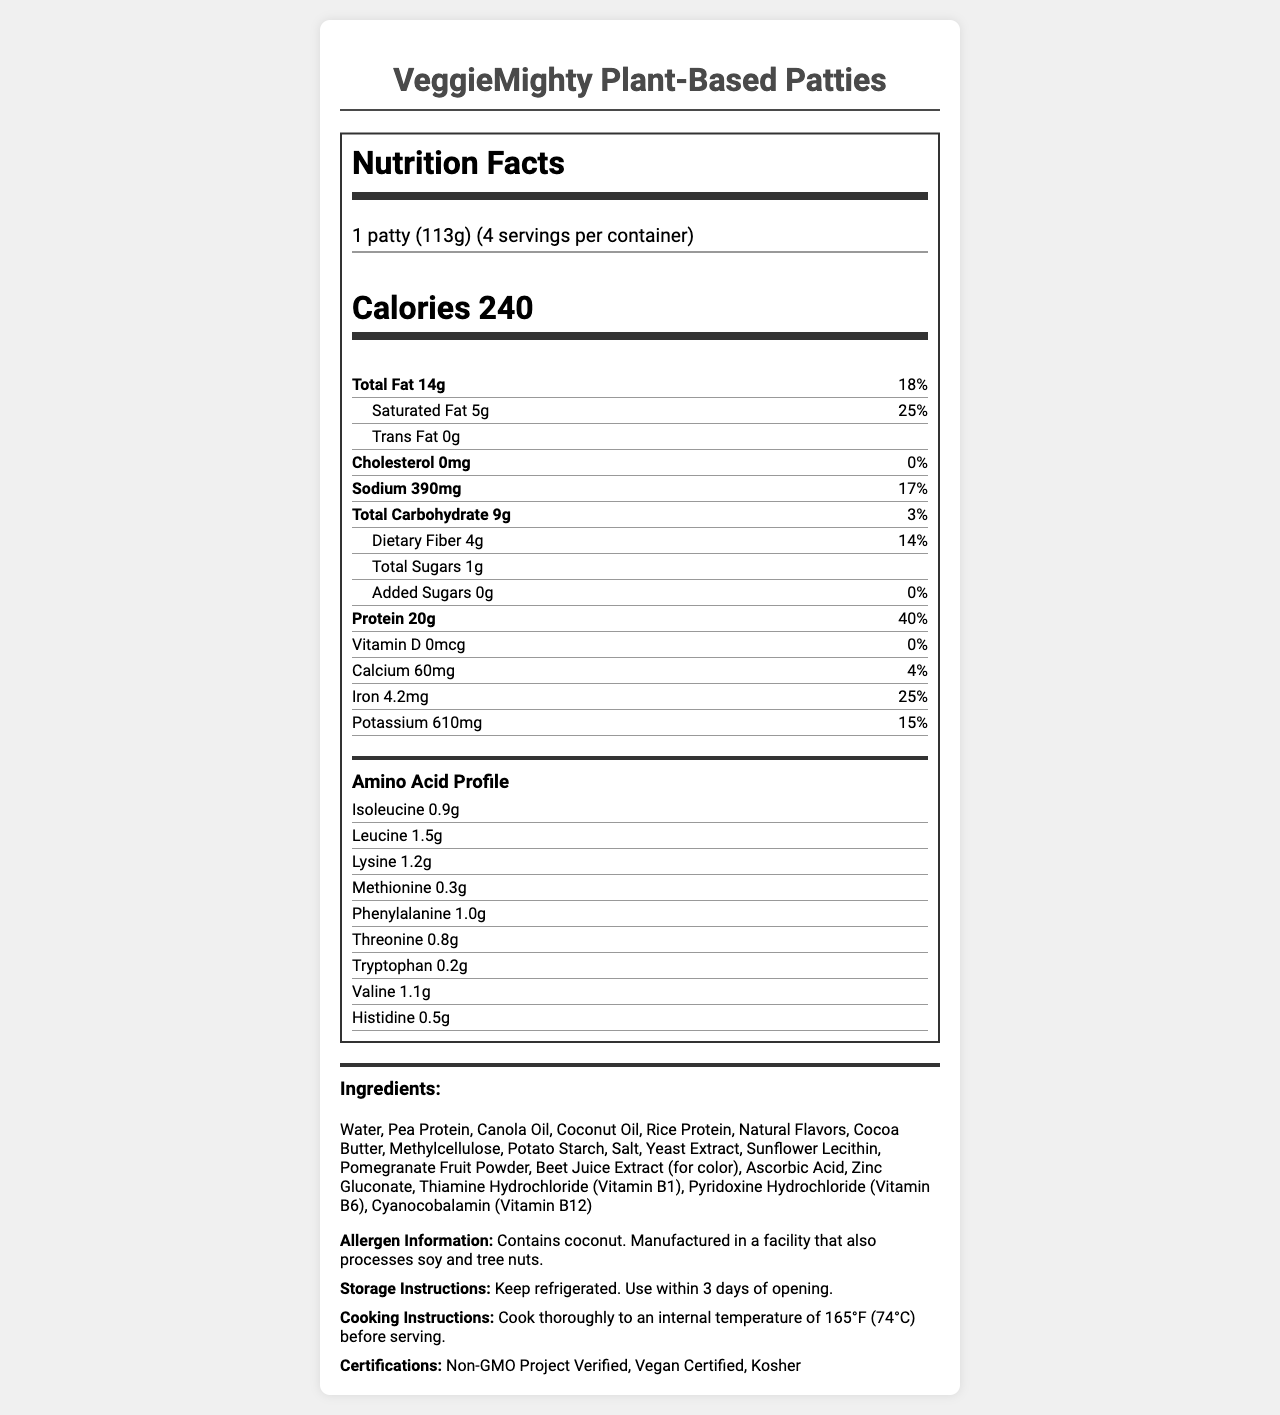What is the serving size for VeggieMighty Plant-Based Patties? The serving size is clearly mentioned at the start of the Nutrition Facts section as "1 patty (113g)".
Answer: 1 patty (113g) How many servings are there per container? The servings per container are listed right after the serving size as "4 servings per container".
Answer: 4 What amount of protein is in one serving of VeggieMighty Plant-Based Patties? The protein content is specified in the Nutrition Facts section as "Protein 20g".
Answer: 20g How many calories are in one serving? The calories are prominently displayed at the top of the Nutrition Facts section as "Calories 240".
Answer: 240 What percentage of the daily value of iron does one serving provide? In the Nutrition Facts section, under "Iron," it shows "25%", which is the daily value percentage.
Answer: 25% Which of these amino acids is present in the highest amount in VeggieMighty Plant-Based Patties? 1. Isoleucine 2. Lysine 3. Leucine 4. Valine By comparing the amounts of each amino acid listed under the Amino Acid Profile, Leucine has the highest amount at 1.5g.
Answer: 3. Leucine Which certification does the VeggieMighty Plant-Based Patties have? A. Gluten-Free B. Vegan Certified C. USDA Organic D. Fair Trade Under the certifications section, "Vegan Certified" is mentioned as one of the certifications.
Answer: B. Vegan Certified Does the product contain any cholesterol? According to the Nutrition Facts, the cholesterol content is "0mg", indicating it doesn't contain any cholesterol.
Answer: No Summarize the main nutrients and the nutritional profile of the VeggieMighty Plant-Based Patties This summary captures the main nutritional values and amino acid profile as presented in the Nutrition Facts section.
Answer: The VeggieMighty Plant-Based Patties have a serving size of 113g per patty, containing 240 calories. Each serving has 14g total fat, 5g saturated fat, 0g trans fat, 0mg cholesterol, 390mg sodium, 9g total carbohydrates, 4g dietary fiber, 1g total sugars, and 20g protein. The patty also offers an amino acid profile and various vitamins and minerals. What is the internal temperature required for cooking the patties? The cooking instructions state to cook thoroughly to an internal temperature of 165°F (74°C).
Answer: 165°F (74°C) Is there any added sugar in VeggieMighty Plant-Based Patties? The Nutrition Facts show "Added Sugars 0g," indicating there is no added sugar.
Answer: No Is the product gluten-free? The document doesn't provide any specific information regarding whether the product is gluten-free or not.
Answer: Cannot be determined What should you do with the product after opening it? The storage instructions specify to "Keep refrigerated. Use within 3 days of opening."
Answer: Use within 3 days of opening Which allergen is explicitly mentioned to be contained in the product? The allergen information states "Contains coconut."
Answer: Coconut 